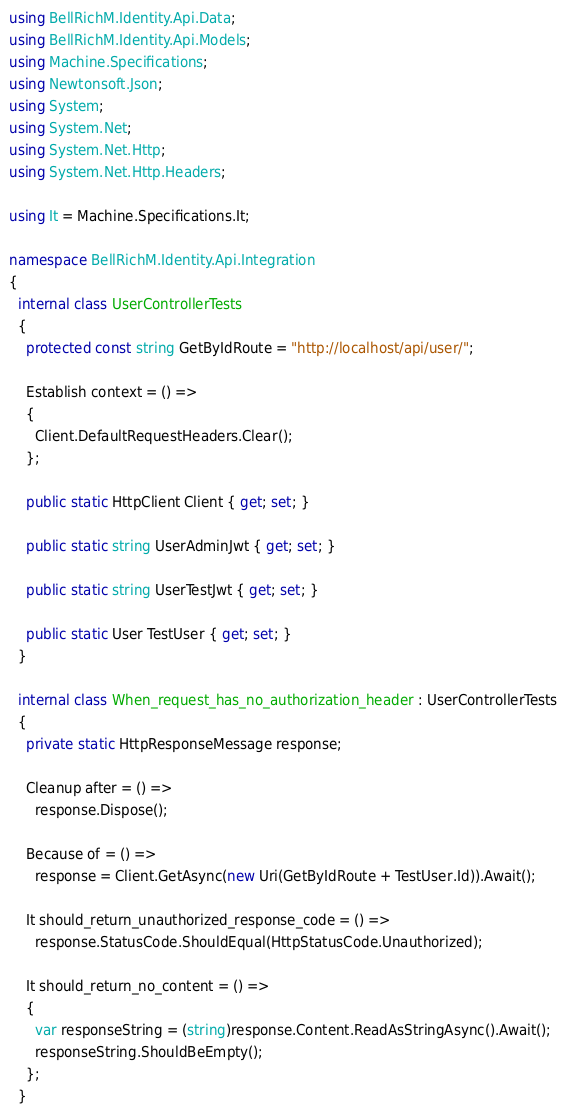<code> <loc_0><loc_0><loc_500><loc_500><_C#_>using BellRichM.Identity.Api.Data;
using BellRichM.Identity.Api.Models;
using Machine.Specifications;
using Newtonsoft.Json;
using System;
using System.Net;
using System.Net.Http;
using System.Net.Http.Headers;

using It = Machine.Specifications.It;

namespace BellRichM.Identity.Api.Integration
{
  internal class UserControllerTests
  {
    protected const string GetByIdRoute = "http://localhost/api/user/";

    Establish context = () =>
    {
      Client.DefaultRequestHeaders.Clear();
    };

    public static HttpClient Client { get; set; }

    public static string UserAdminJwt { get; set; }

    public static string UserTestJwt { get; set; }

    public static User TestUser { get; set; }
  }

  internal class When_request_has_no_authorization_header : UserControllerTests
  {
    private static HttpResponseMessage response;

    Cleanup after = () =>
      response.Dispose();

    Because of = () =>
      response = Client.GetAsync(new Uri(GetByIdRoute + TestUser.Id)).Await();

    It should_return_unauthorized_response_code = () =>
      response.StatusCode.ShouldEqual(HttpStatusCode.Unauthorized);

    It should_return_no_content = () =>
    {
      var responseString = (string)response.Content.ReadAsStringAsync().Await();
      responseString.ShouldBeEmpty();
    };
  }
</code> 